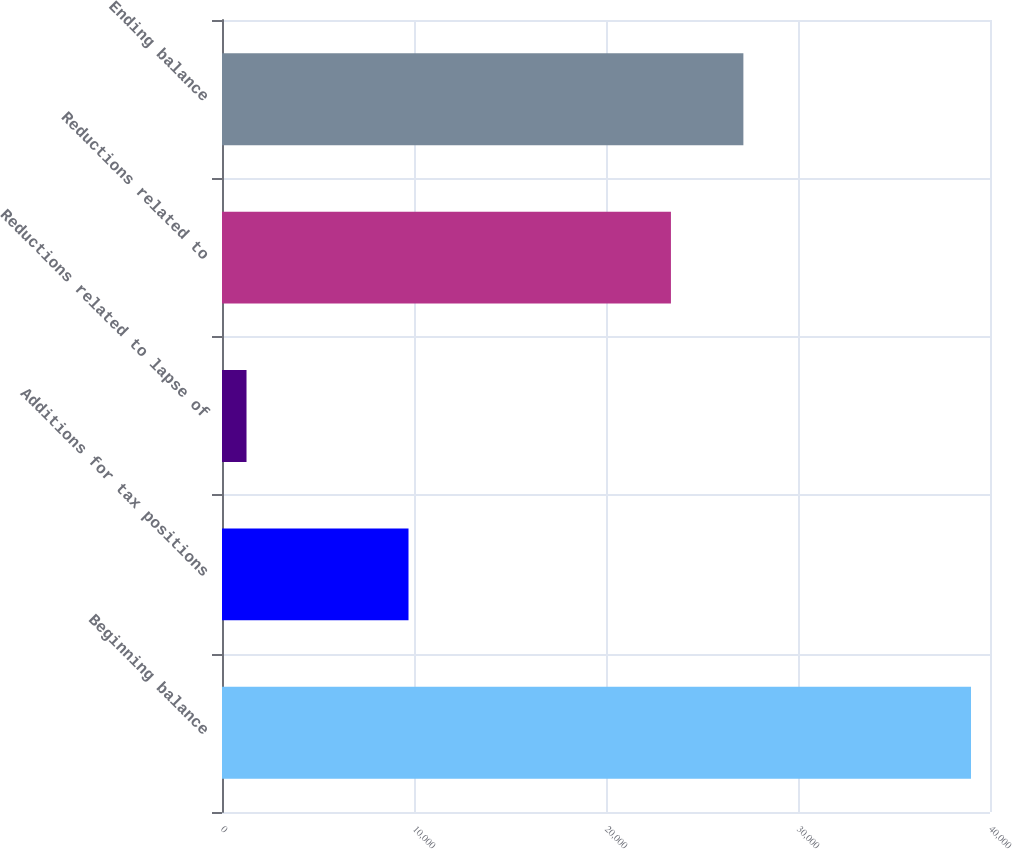<chart> <loc_0><loc_0><loc_500><loc_500><bar_chart><fcel>Beginning balance<fcel>Additions for tax positions<fcel>Reductions related to lapse of<fcel>Reductions related to<fcel>Ending balance<nl><fcel>39011<fcel>9714<fcel>1277<fcel>23382<fcel>27155.4<nl></chart> 